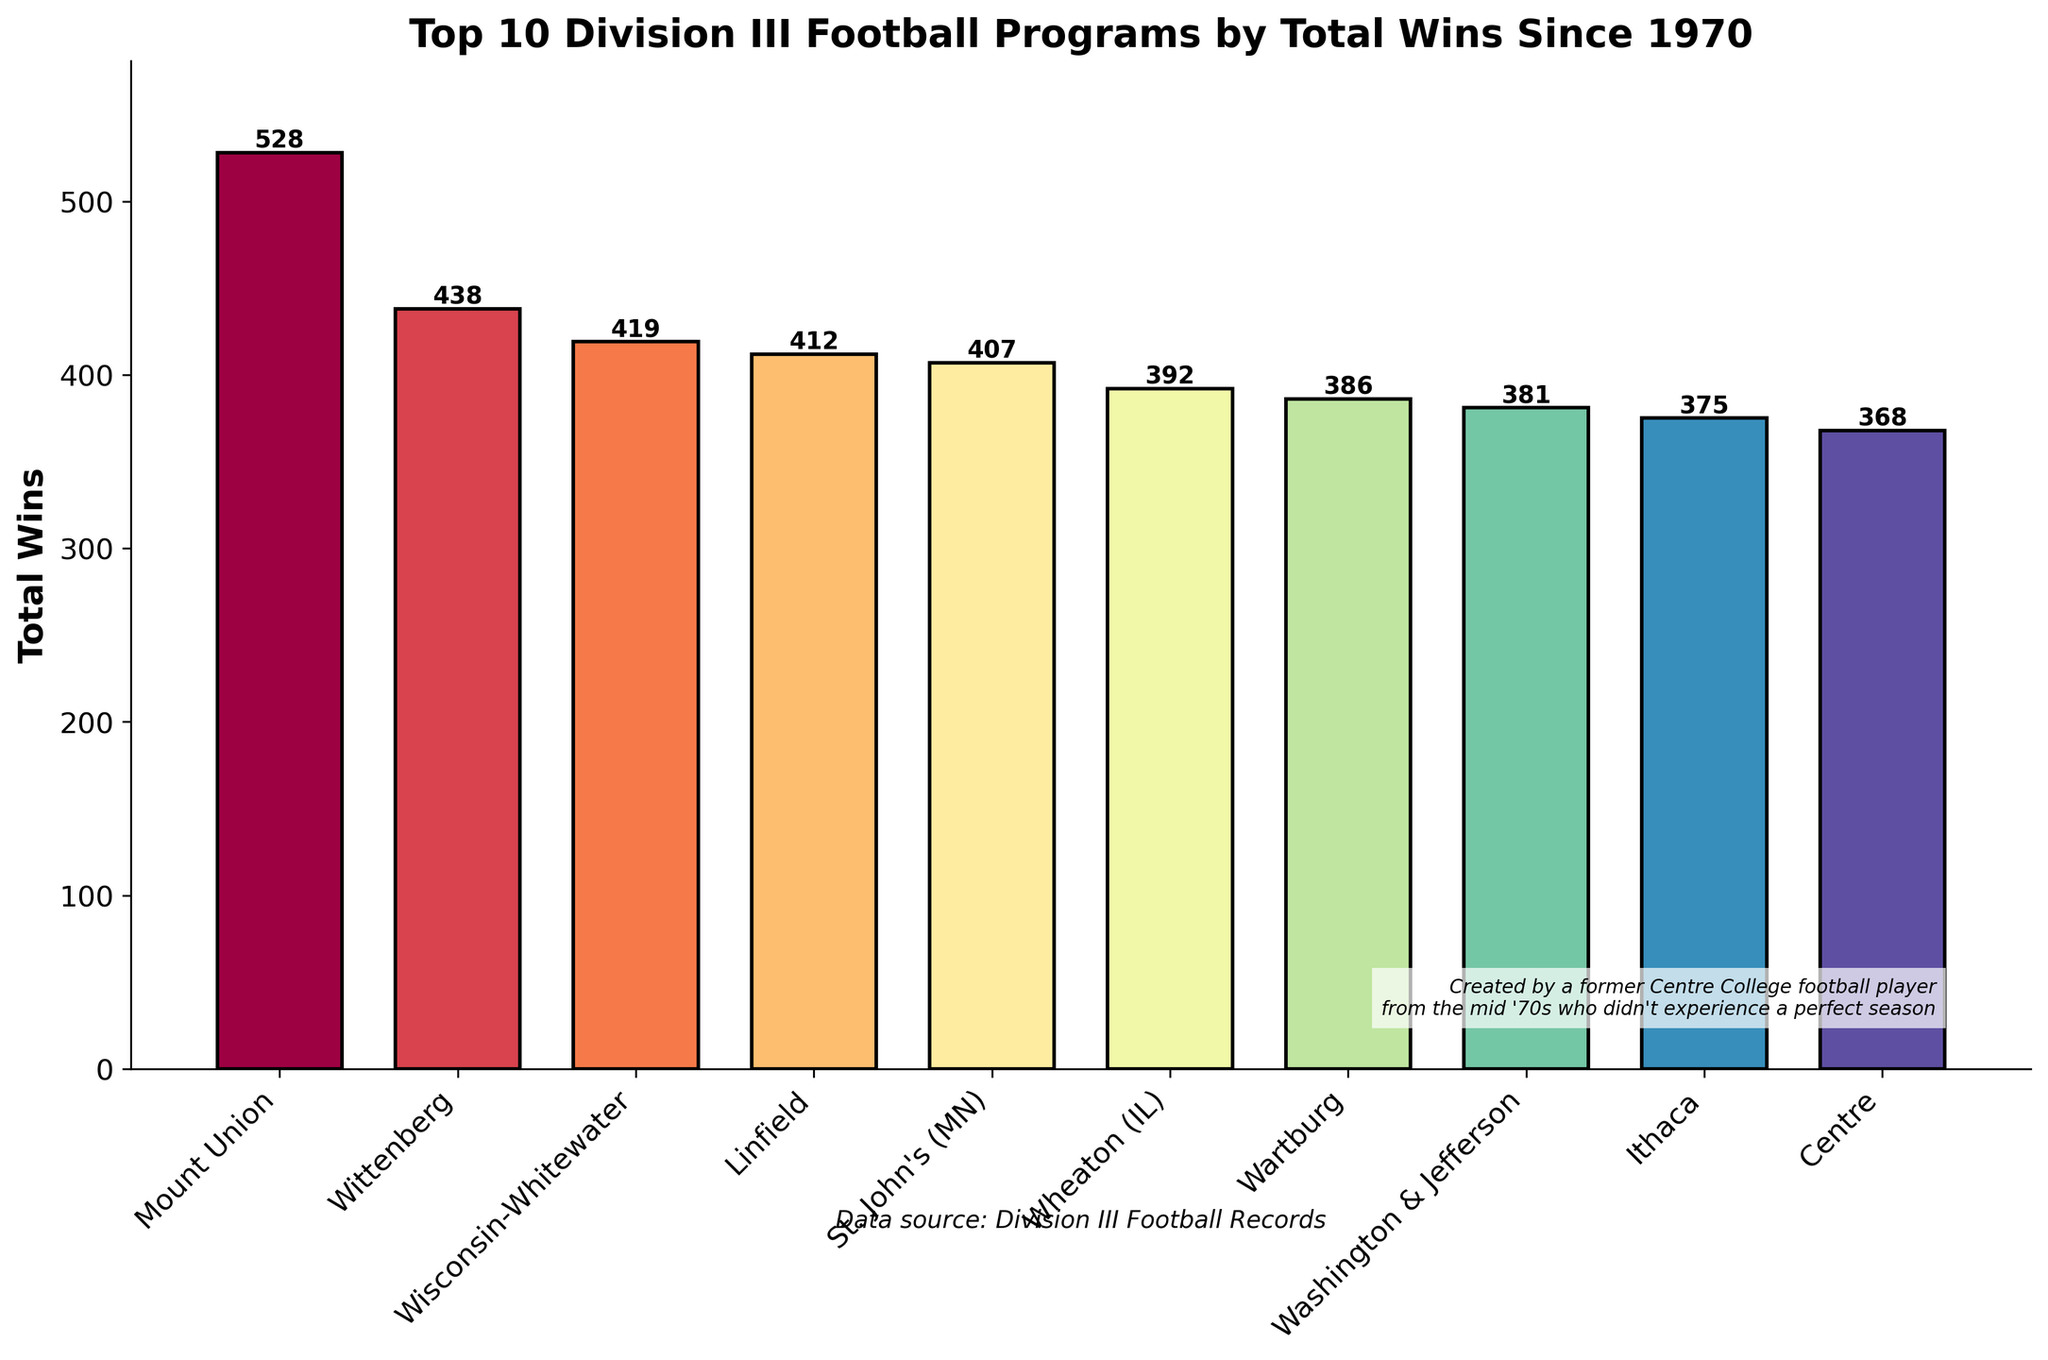What football program has the highest total wins since 1970? The bar corresponding to each football program has a height indicating the total wins. The bar for "Mount Union" is the tallest, showing 528 wins.
Answer: Mount Union Which two programs have total wins closest to each other? Compare the heights of the bars visually to find two programs with similar heights. "Washington & Jefferson" and "Ithaca" have 381 and 375 wins respectively, the closest in total wins.
Answer: Washington & Jefferson and Ithaca What is the total number of wins for the top three programs combined? The top three programs by total wins are "Mount Union," "Wittenberg," and "Wisconsin-Whitewater," with 528, 438, and 419 wins respectively. Summing these gives 528 + 438 + 419 = 1385.
Answer: 1385 How many more wins does Mount Union have compared to Centre? The bar for "Mount Union" shows 528 wins, and the bar for "Centre" shows 368 wins. The difference is 528 - 368 = 160.
Answer: 160 Order the programs by total wins from highest to lowest. Visually assess the height of the bars from tallest to shortest and list the programs accordingly. The sorted order is: Mount Union, Wittenberg, Wisconsin-Whitewater, Linfield, St. John's (MN), Wheaton (IL), Wartburg, Washington & Jefferson, Ithaca, Centre.
Answer: Mount Union, Wittenberg, Wisconsin-Whitewater, Linfield, St. John's (MN), Wheaton (IL), Wartburg, Washington & Jefferson, Ithaca, Centre What is the difference in total wins between Wartburg and Wheaton (IL)? Find the heights of the bars for "Wartburg" (386 wins) and "Wheaton (IL)" (392 wins). The difference is 392 - 386 = 6.
Answer: 6 What is the average total wins of all 10 programs? Sum the total wins of all programs and divide by 10. The total wins are 528 + 438 + 419 + 412 + 407 + 392 + 386 + 381 + 375 + 368 = 4106. The average is 4106 / 10 = 410.6.
Answer: 410.6 Which program has the least total wins, and what is that number? Find the shortest bar, which belongs to "Centre" with 368 wins.
Answer: Centre Comparing Linfield and St. John's (MN), which program has more wins and by how much? The bar for "Linfield" shows 412 wins and for "St. John's (MN)" it shows 407 wins. The difference is 412 - 407 = 5.
Answer: Linfield by 5 What is the visual color gradient used for the bars, and which bar is the lightest? The color scheme applied to the bars suggests a gradient. "Mount Union" appears in the lightest color from the top of the gradient range used.
Answer: Mount Union 